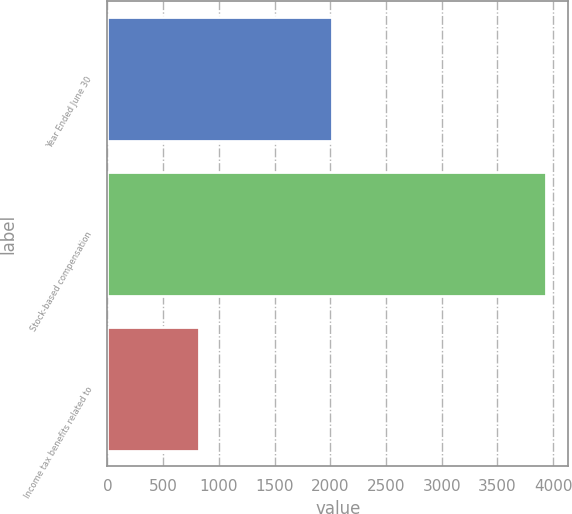Convert chart to OTSL. <chart><loc_0><loc_0><loc_500><loc_500><bar_chart><fcel>Year Ended June 30<fcel>Stock-based compensation<fcel>Income tax benefits related to<nl><fcel>2018<fcel>3940<fcel>823<nl></chart> 